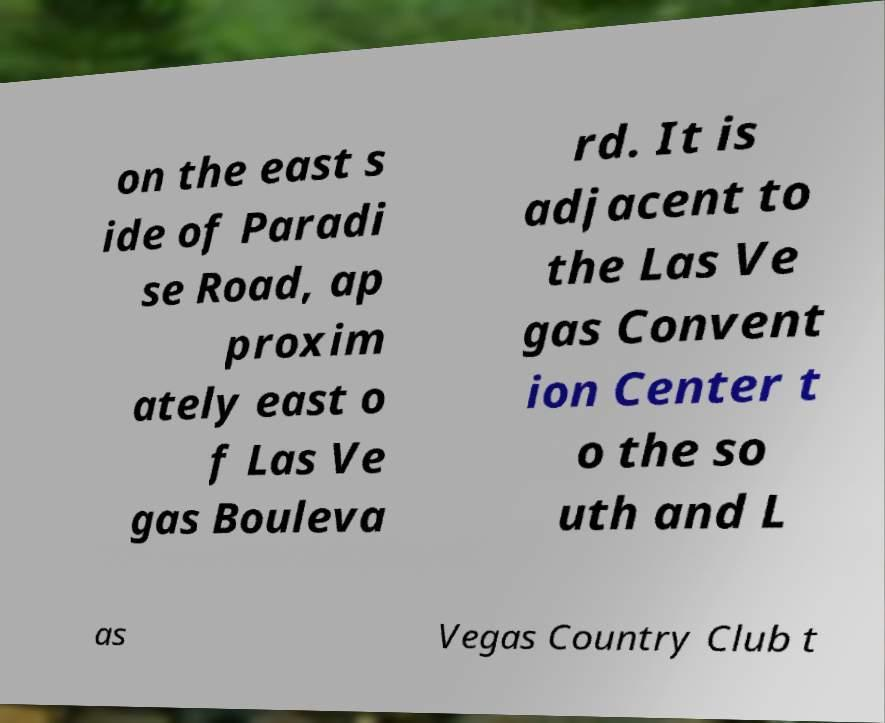There's text embedded in this image that I need extracted. Can you transcribe it verbatim? on the east s ide of Paradi se Road, ap proxim ately east o f Las Ve gas Bouleva rd. It is adjacent to the Las Ve gas Convent ion Center t o the so uth and L as Vegas Country Club t 